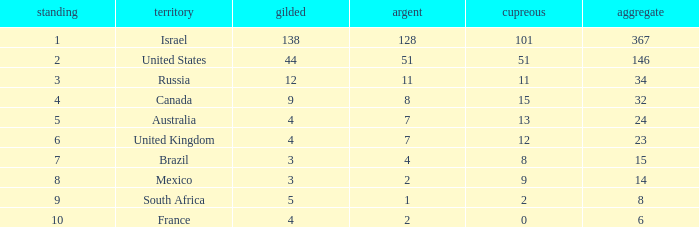What is the gold medal count for the country with a total greater than 32 and more than 128 silvers? None. 